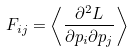<formula> <loc_0><loc_0><loc_500><loc_500>F _ { i j } = \left \langle \frac { \partial ^ { 2 } L } { \partial p _ { i } \partial p _ { j } } \right \rangle</formula> 